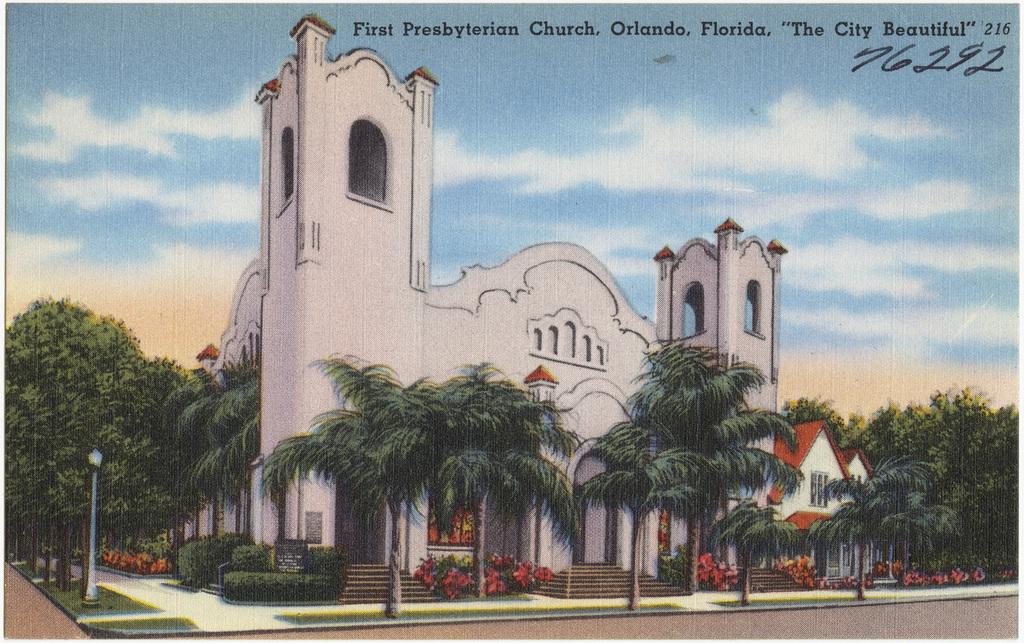What is featured on the poster in the image? There is a poster in the image, which includes a building, trees, and poles. Can you describe the elements depicted on the poster? The poster includes a building, trees, and poles. What type of cork can be seen on the poster? There is no cork present on the poster; it features a building, trees, and poles. How many trucks are visible on the poster? There are no trucks depicted on the poster. 